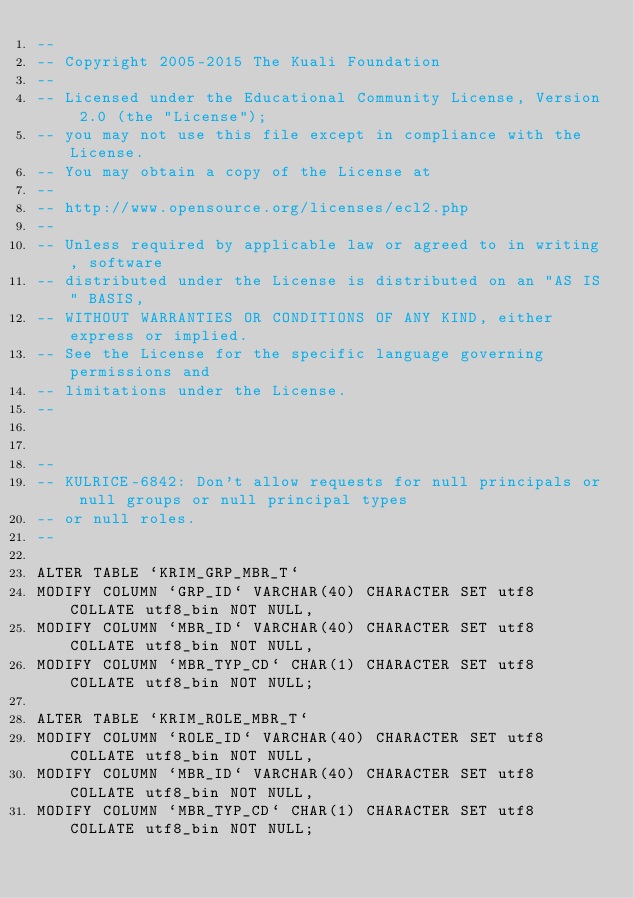Convert code to text. <code><loc_0><loc_0><loc_500><loc_500><_SQL_>--
-- Copyright 2005-2015 The Kuali Foundation
--
-- Licensed under the Educational Community License, Version 2.0 (the "License");
-- you may not use this file except in compliance with the License.
-- You may obtain a copy of the License at
--
-- http://www.opensource.org/licenses/ecl2.php
--
-- Unless required by applicable law or agreed to in writing, software
-- distributed under the License is distributed on an "AS IS" BASIS,
-- WITHOUT WARRANTIES OR CONDITIONS OF ANY KIND, either express or implied.
-- See the License for the specific language governing permissions and
-- limitations under the License.
--


--
-- KULRICE-6842: Don't allow requests for null principals or null groups or null principal types
-- or null roles.
--

ALTER TABLE `KRIM_GRP_MBR_T`
MODIFY COLUMN `GRP_ID` VARCHAR(40) CHARACTER SET utf8 COLLATE utf8_bin NOT NULL,
MODIFY COLUMN `MBR_ID` VARCHAR(40) CHARACTER SET utf8 COLLATE utf8_bin NOT NULL,
MODIFY COLUMN `MBR_TYP_CD` CHAR(1) CHARACTER SET utf8 COLLATE utf8_bin NOT NULL;

ALTER TABLE `KRIM_ROLE_MBR_T`
MODIFY COLUMN `ROLE_ID` VARCHAR(40) CHARACTER SET utf8 COLLATE utf8_bin NOT NULL,
MODIFY COLUMN `MBR_ID` VARCHAR(40) CHARACTER SET utf8 COLLATE utf8_bin NOT NULL,
MODIFY COLUMN `MBR_TYP_CD` CHAR(1) CHARACTER SET utf8 COLLATE utf8_bin NOT NULL;
</code> 